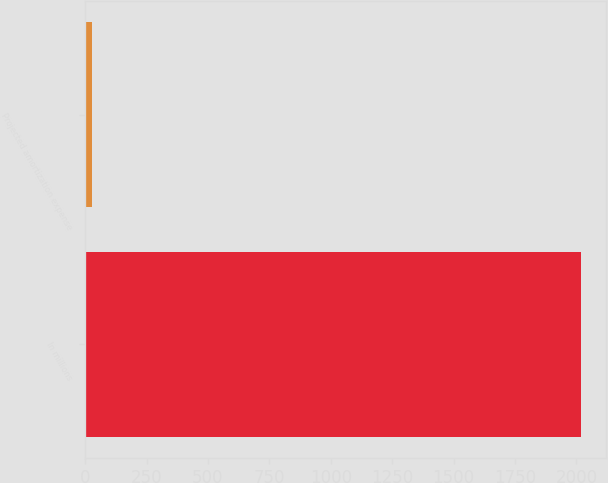Convert chart to OTSL. <chart><loc_0><loc_0><loc_500><loc_500><bar_chart><fcel>In millions<fcel>Projected amortization expense<nl><fcel>2018<fcel>27<nl></chart> 